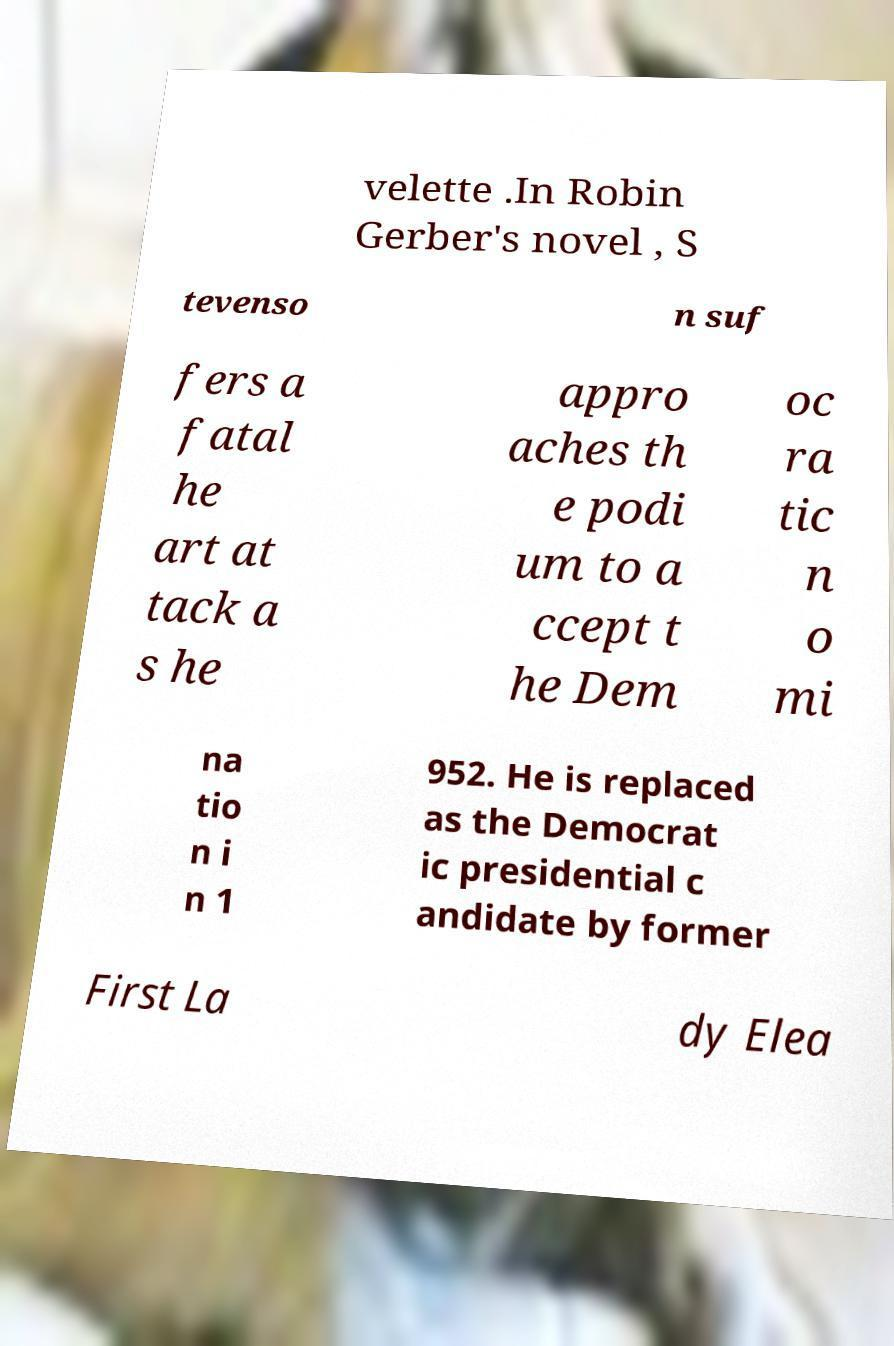Could you extract and type out the text from this image? velette .In Robin Gerber's novel , S tevenso n suf fers a fatal he art at tack a s he appro aches th e podi um to a ccept t he Dem oc ra tic n o mi na tio n i n 1 952. He is replaced as the Democrat ic presidential c andidate by former First La dy Elea 